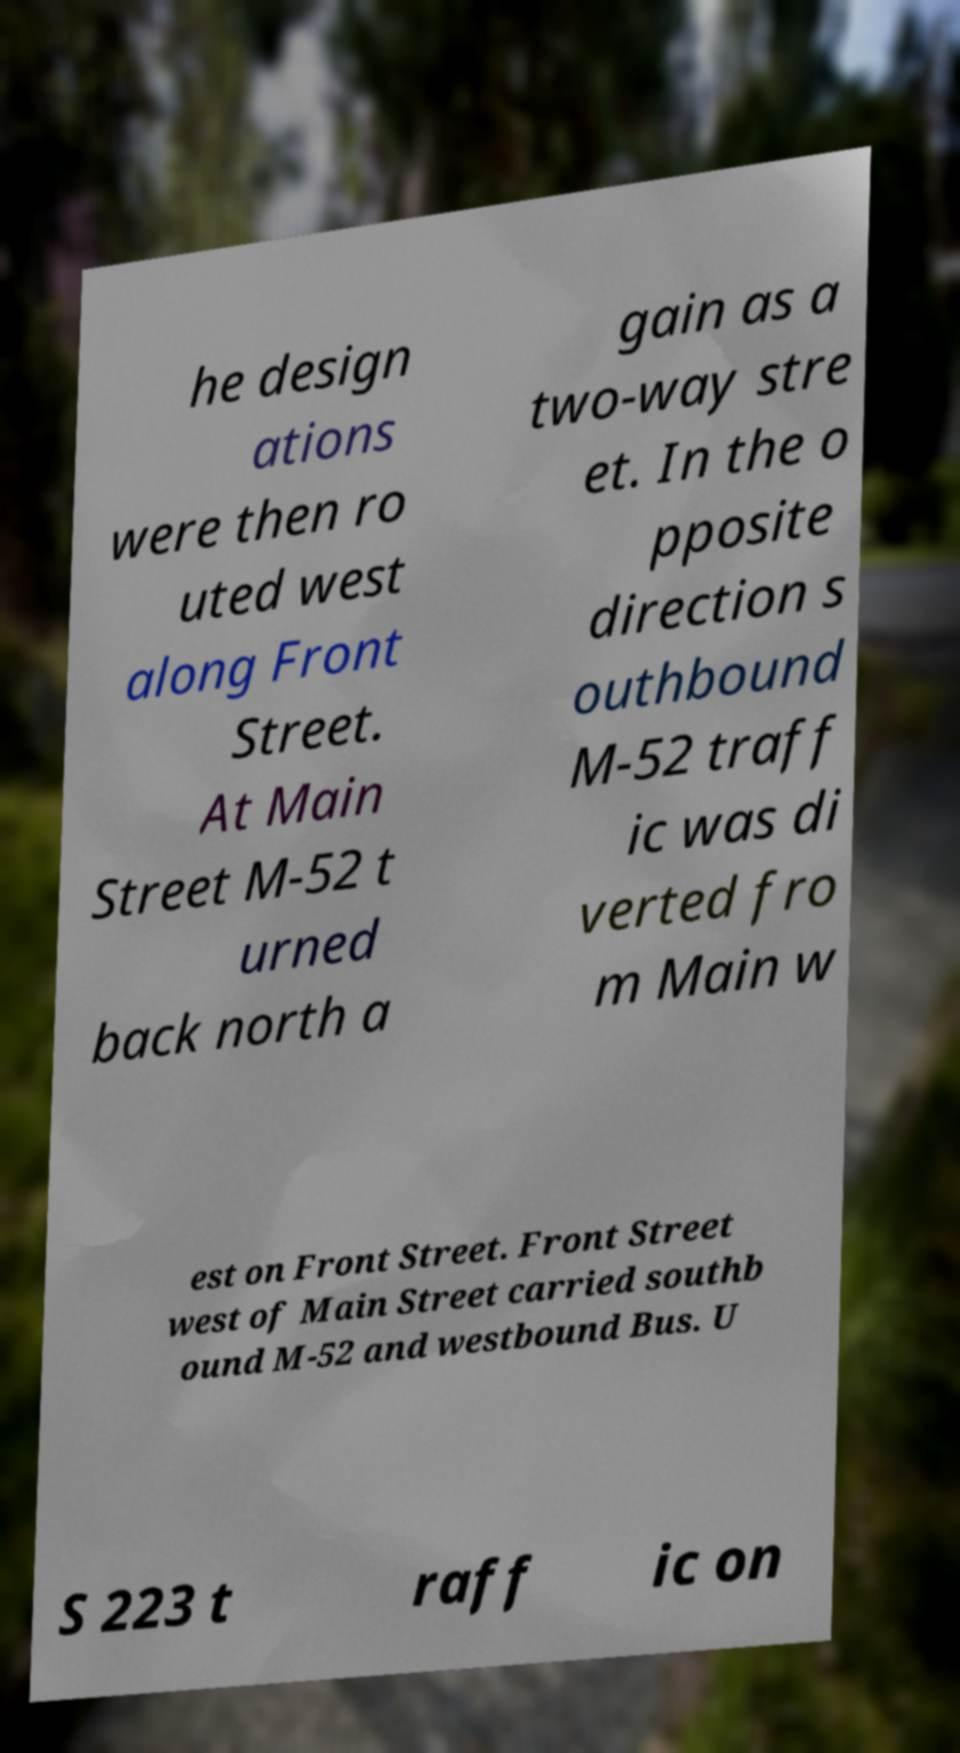There's text embedded in this image that I need extracted. Can you transcribe it verbatim? he design ations were then ro uted west along Front Street. At Main Street M-52 t urned back north a gain as a two-way stre et. In the o pposite direction s outhbound M-52 traff ic was di verted fro m Main w est on Front Street. Front Street west of Main Street carried southb ound M-52 and westbound Bus. U S 223 t raff ic on 